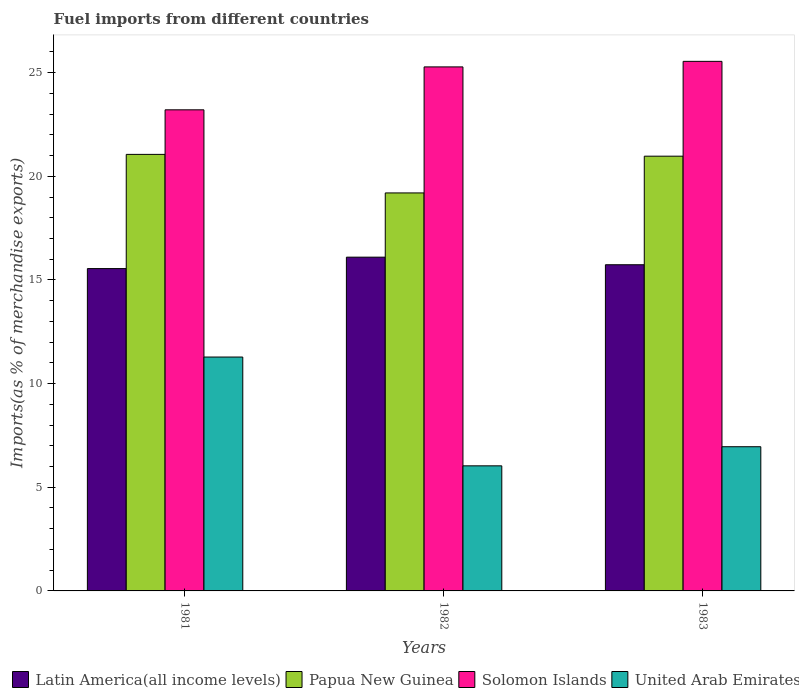Are the number of bars on each tick of the X-axis equal?
Provide a short and direct response. Yes. What is the percentage of imports to different countries in Papua New Guinea in 1982?
Your answer should be very brief. 19.2. Across all years, what is the maximum percentage of imports to different countries in Solomon Islands?
Give a very brief answer. 25.54. Across all years, what is the minimum percentage of imports to different countries in Latin America(all income levels)?
Your answer should be compact. 15.55. In which year was the percentage of imports to different countries in United Arab Emirates minimum?
Give a very brief answer. 1982. What is the total percentage of imports to different countries in Solomon Islands in the graph?
Make the answer very short. 74.03. What is the difference between the percentage of imports to different countries in Latin America(all income levels) in 1981 and that in 1983?
Keep it short and to the point. -0.19. What is the difference between the percentage of imports to different countries in Papua New Guinea in 1982 and the percentage of imports to different countries in Solomon Islands in 1983?
Provide a succinct answer. -6.35. What is the average percentage of imports to different countries in Latin America(all income levels) per year?
Your answer should be compact. 15.79. In the year 1983, what is the difference between the percentage of imports to different countries in Papua New Guinea and percentage of imports to different countries in United Arab Emirates?
Provide a short and direct response. 14.01. In how many years, is the percentage of imports to different countries in Solomon Islands greater than 7 %?
Keep it short and to the point. 3. What is the ratio of the percentage of imports to different countries in Solomon Islands in 1981 to that in 1982?
Offer a very short reply. 0.92. Is the percentage of imports to different countries in Latin America(all income levels) in 1981 less than that in 1982?
Offer a very short reply. Yes. Is the difference between the percentage of imports to different countries in Papua New Guinea in 1982 and 1983 greater than the difference between the percentage of imports to different countries in United Arab Emirates in 1982 and 1983?
Offer a very short reply. No. What is the difference between the highest and the second highest percentage of imports to different countries in United Arab Emirates?
Keep it short and to the point. 4.33. What is the difference between the highest and the lowest percentage of imports to different countries in Solomon Islands?
Ensure brevity in your answer.  2.34. What does the 2nd bar from the left in 1981 represents?
Ensure brevity in your answer.  Papua New Guinea. What does the 1st bar from the right in 1981 represents?
Your answer should be compact. United Arab Emirates. How many years are there in the graph?
Provide a short and direct response. 3. Does the graph contain grids?
Your answer should be very brief. No. Where does the legend appear in the graph?
Your answer should be compact. Bottom left. What is the title of the graph?
Keep it short and to the point. Fuel imports from different countries. What is the label or title of the Y-axis?
Offer a terse response. Imports(as % of merchandise exports). What is the Imports(as % of merchandise exports) of Latin America(all income levels) in 1981?
Provide a succinct answer. 15.55. What is the Imports(as % of merchandise exports) in Papua New Guinea in 1981?
Your answer should be compact. 21.06. What is the Imports(as % of merchandise exports) in Solomon Islands in 1981?
Your answer should be compact. 23.21. What is the Imports(as % of merchandise exports) of United Arab Emirates in 1981?
Your response must be concise. 11.28. What is the Imports(as % of merchandise exports) in Latin America(all income levels) in 1982?
Provide a short and direct response. 16.1. What is the Imports(as % of merchandise exports) in Papua New Guinea in 1982?
Your answer should be compact. 19.2. What is the Imports(as % of merchandise exports) in Solomon Islands in 1982?
Provide a short and direct response. 25.28. What is the Imports(as % of merchandise exports) in United Arab Emirates in 1982?
Offer a very short reply. 6.03. What is the Imports(as % of merchandise exports) in Latin America(all income levels) in 1983?
Your answer should be very brief. 15.73. What is the Imports(as % of merchandise exports) of Papua New Guinea in 1983?
Your answer should be compact. 20.97. What is the Imports(as % of merchandise exports) of Solomon Islands in 1983?
Provide a short and direct response. 25.54. What is the Imports(as % of merchandise exports) in United Arab Emirates in 1983?
Make the answer very short. 6.96. Across all years, what is the maximum Imports(as % of merchandise exports) in Latin America(all income levels)?
Offer a very short reply. 16.1. Across all years, what is the maximum Imports(as % of merchandise exports) of Papua New Guinea?
Offer a terse response. 21.06. Across all years, what is the maximum Imports(as % of merchandise exports) of Solomon Islands?
Your answer should be very brief. 25.54. Across all years, what is the maximum Imports(as % of merchandise exports) in United Arab Emirates?
Your response must be concise. 11.28. Across all years, what is the minimum Imports(as % of merchandise exports) of Latin America(all income levels)?
Your response must be concise. 15.55. Across all years, what is the minimum Imports(as % of merchandise exports) in Papua New Guinea?
Your response must be concise. 19.2. Across all years, what is the minimum Imports(as % of merchandise exports) of Solomon Islands?
Ensure brevity in your answer.  23.21. Across all years, what is the minimum Imports(as % of merchandise exports) in United Arab Emirates?
Provide a short and direct response. 6.03. What is the total Imports(as % of merchandise exports) of Latin America(all income levels) in the graph?
Make the answer very short. 47.38. What is the total Imports(as % of merchandise exports) of Papua New Guinea in the graph?
Keep it short and to the point. 61.22. What is the total Imports(as % of merchandise exports) in Solomon Islands in the graph?
Provide a short and direct response. 74.03. What is the total Imports(as % of merchandise exports) of United Arab Emirates in the graph?
Your answer should be very brief. 24.27. What is the difference between the Imports(as % of merchandise exports) in Latin America(all income levels) in 1981 and that in 1982?
Ensure brevity in your answer.  -0.55. What is the difference between the Imports(as % of merchandise exports) of Papua New Guinea in 1981 and that in 1982?
Make the answer very short. 1.86. What is the difference between the Imports(as % of merchandise exports) of Solomon Islands in 1981 and that in 1982?
Give a very brief answer. -2.07. What is the difference between the Imports(as % of merchandise exports) of United Arab Emirates in 1981 and that in 1982?
Provide a succinct answer. 5.25. What is the difference between the Imports(as % of merchandise exports) in Latin America(all income levels) in 1981 and that in 1983?
Provide a succinct answer. -0.19. What is the difference between the Imports(as % of merchandise exports) of Papua New Guinea in 1981 and that in 1983?
Make the answer very short. 0.09. What is the difference between the Imports(as % of merchandise exports) of Solomon Islands in 1981 and that in 1983?
Provide a short and direct response. -2.34. What is the difference between the Imports(as % of merchandise exports) of United Arab Emirates in 1981 and that in 1983?
Your answer should be very brief. 4.33. What is the difference between the Imports(as % of merchandise exports) in Latin America(all income levels) in 1982 and that in 1983?
Your response must be concise. 0.37. What is the difference between the Imports(as % of merchandise exports) in Papua New Guinea in 1982 and that in 1983?
Make the answer very short. -1.77. What is the difference between the Imports(as % of merchandise exports) in Solomon Islands in 1982 and that in 1983?
Ensure brevity in your answer.  -0.27. What is the difference between the Imports(as % of merchandise exports) of United Arab Emirates in 1982 and that in 1983?
Keep it short and to the point. -0.92. What is the difference between the Imports(as % of merchandise exports) in Latin America(all income levels) in 1981 and the Imports(as % of merchandise exports) in Papua New Guinea in 1982?
Keep it short and to the point. -3.65. What is the difference between the Imports(as % of merchandise exports) of Latin America(all income levels) in 1981 and the Imports(as % of merchandise exports) of Solomon Islands in 1982?
Provide a succinct answer. -9.73. What is the difference between the Imports(as % of merchandise exports) of Latin America(all income levels) in 1981 and the Imports(as % of merchandise exports) of United Arab Emirates in 1982?
Your answer should be compact. 9.51. What is the difference between the Imports(as % of merchandise exports) in Papua New Guinea in 1981 and the Imports(as % of merchandise exports) in Solomon Islands in 1982?
Offer a very short reply. -4.22. What is the difference between the Imports(as % of merchandise exports) of Papua New Guinea in 1981 and the Imports(as % of merchandise exports) of United Arab Emirates in 1982?
Give a very brief answer. 15.02. What is the difference between the Imports(as % of merchandise exports) in Solomon Islands in 1981 and the Imports(as % of merchandise exports) in United Arab Emirates in 1982?
Keep it short and to the point. 17.17. What is the difference between the Imports(as % of merchandise exports) of Latin America(all income levels) in 1981 and the Imports(as % of merchandise exports) of Papua New Guinea in 1983?
Give a very brief answer. -5.42. What is the difference between the Imports(as % of merchandise exports) in Latin America(all income levels) in 1981 and the Imports(as % of merchandise exports) in Solomon Islands in 1983?
Give a very brief answer. -10. What is the difference between the Imports(as % of merchandise exports) of Latin America(all income levels) in 1981 and the Imports(as % of merchandise exports) of United Arab Emirates in 1983?
Provide a succinct answer. 8.59. What is the difference between the Imports(as % of merchandise exports) in Papua New Guinea in 1981 and the Imports(as % of merchandise exports) in Solomon Islands in 1983?
Give a very brief answer. -4.49. What is the difference between the Imports(as % of merchandise exports) of Papua New Guinea in 1981 and the Imports(as % of merchandise exports) of United Arab Emirates in 1983?
Make the answer very short. 14.1. What is the difference between the Imports(as % of merchandise exports) of Solomon Islands in 1981 and the Imports(as % of merchandise exports) of United Arab Emirates in 1983?
Ensure brevity in your answer.  16.25. What is the difference between the Imports(as % of merchandise exports) in Latin America(all income levels) in 1982 and the Imports(as % of merchandise exports) in Papua New Guinea in 1983?
Your response must be concise. -4.87. What is the difference between the Imports(as % of merchandise exports) of Latin America(all income levels) in 1982 and the Imports(as % of merchandise exports) of Solomon Islands in 1983?
Offer a very short reply. -9.44. What is the difference between the Imports(as % of merchandise exports) of Latin America(all income levels) in 1982 and the Imports(as % of merchandise exports) of United Arab Emirates in 1983?
Keep it short and to the point. 9.14. What is the difference between the Imports(as % of merchandise exports) of Papua New Guinea in 1982 and the Imports(as % of merchandise exports) of Solomon Islands in 1983?
Provide a succinct answer. -6.35. What is the difference between the Imports(as % of merchandise exports) in Papua New Guinea in 1982 and the Imports(as % of merchandise exports) in United Arab Emirates in 1983?
Your answer should be very brief. 12.24. What is the difference between the Imports(as % of merchandise exports) of Solomon Islands in 1982 and the Imports(as % of merchandise exports) of United Arab Emirates in 1983?
Your answer should be compact. 18.32. What is the average Imports(as % of merchandise exports) of Latin America(all income levels) per year?
Your answer should be very brief. 15.79. What is the average Imports(as % of merchandise exports) of Papua New Guinea per year?
Give a very brief answer. 20.41. What is the average Imports(as % of merchandise exports) in Solomon Islands per year?
Your response must be concise. 24.68. What is the average Imports(as % of merchandise exports) in United Arab Emirates per year?
Make the answer very short. 8.09. In the year 1981, what is the difference between the Imports(as % of merchandise exports) in Latin America(all income levels) and Imports(as % of merchandise exports) in Papua New Guinea?
Make the answer very short. -5.51. In the year 1981, what is the difference between the Imports(as % of merchandise exports) in Latin America(all income levels) and Imports(as % of merchandise exports) in Solomon Islands?
Your answer should be compact. -7.66. In the year 1981, what is the difference between the Imports(as % of merchandise exports) in Latin America(all income levels) and Imports(as % of merchandise exports) in United Arab Emirates?
Provide a succinct answer. 4.27. In the year 1981, what is the difference between the Imports(as % of merchandise exports) in Papua New Guinea and Imports(as % of merchandise exports) in Solomon Islands?
Ensure brevity in your answer.  -2.15. In the year 1981, what is the difference between the Imports(as % of merchandise exports) of Papua New Guinea and Imports(as % of merchandise exports) of United Arab Emirates?
Your response must be concise. 9.78. In the year 1981, what is the difference between the Imports(as % of merchandise exports) in Solomon Islands and Imports(as % of merchandise exports) in United Arab Emirates?
Your answer should be very brief. 11.93. In the year 1982, what is the difference between the Imports(as % of merchandise exports) of Latin America(all income levels) and Imports(as % of merchandise exports) of Papua New Guinea?
Offer a terse response. -3.1. In the year 1982, what is the difference between the Imports(as % of merchandise exports) in Latin America(all income levels) and Imports(as % of merchandise exports) in Solomon Islands?
Your response must be concise. -9.18. In the year 1982, what is the difference between the Imports(as % of merchandise exports) in Latin America(all income levels) and Imports(as % of merchandise exports) in United Arab Emirates?
Make the answer very short. 10.07. In the year 1982, what is the difference between the Imports(as % of merchandise exports) in Papua New Guinea and Imports(as % of merchandise exports) in Solomon Islands?
Ensure brevity in your answer.  -6.08. In the year 1982, what is the difference between the Imports(as % of merchandise exports) of Papua New Guinea and Imports(as % of merchandise exports) of United Arab Emirates?
Provide a short and direct response. 13.16. In the year 1982, what is the difference between the Imports(as % of merchandise exports) of Solomon Islands and Imports(as % of merchandise exports) of United Arab Emirates?
Ensure brevity in your answer.  19.24. In the year 1983, what is the difference between the Imports(as % of merchandise exports) of Latin America(all income levels) and Imports(as % of merchandise exports) of Papua New Guinea?
Offer a very short reply. -5.24. In the year 1983, what is the difference between the Imports(as % of merchandise exports) in Latin America(all income levels) and Imports(as % of merchandise exports) in Solomon Islands?
Provide a short and direct response. -9.81. In the year 1983, what is the difference between the Imports(as % of merchandise exports) in Latin America(all income levels) and Imports(as % of merchandise exports) in United Arab Emirates?
Your answer should be compact. 8.78. In the year 1983, what is the difference between the Imports(as % of merchandise exports) in Papua New Guinea and Imports(as % of merchandise exports) in Solomon Islands?
Provide a short and direct response. -4.57. In the year 1983, what is the difference between the Imports(as % of merchandise exports) of Papua New Guinea and Imports(as % of merchandise exports) of United Arab Emirates?
Offer a very short reply. 14.01. In the year 1983, what is the difference between the Imports(as % of merchandise exports) in Solomon Islands and Imports(as % of merchandise exports) in United Arab Emirates?
Offer a very short reply. 18.59. What is the ratio of the Imports(as % of merchandise exports) of Latin America(all income levels) in 1981 to that in 1982?
Provide a short and direct response. 0.97. What is the ratio of the Imports(as % of merchandise exports) of Papua New Guinea in 1981 to that in 1982?
Offer a terse response. 1.1. What is the ratio of the Imports(as % of merchandise exports) of Solomon Islands in 1981 to that in 1982?
Ensure brevity in your answer.  0.92. What is the ratio of the Imports(as % of merchandise exports) in United Arab Emirates in 1981 to that in 1982?
Offer a terse response. 1.87. What is the ratio of the Imports(as % of merchandise exports) of Latin America(all income levels) in 1981 to that in 1983?
Your response must be concise. 0.99. What is the ratio of the Imports(as % of merchandise exports) of Papua New Guinea in 1981 to that in 1983?
Provide a short and direct response. 1. What is the ratio of the Imports(as % of merchandise exports) in Solomon Islands in 1981 to that in 1983?
Your response must be concise. 0.91. What is the ratio of the Imports(as % of merchandise exports) in United Arab Emirates in 1981 to that in 1983?
Provide a short and direct response. 1.62. What is the ratio of the Imports(as % of merchandise exports) in Latin America(all income levels) in 1982 to that in 1983?
Offer a terse response. 1.02. What is the ratio of the Imports(as % of merchandise exports) in Papua New Guinea in 1982 to that in 1983?
Keep it short and to the point. 0.92. What is the ratio of the Imports(as % of merchandise exports) of Solomon Islands in 1982 to that in 1983?
Offer a very short reply. 0.99. What is the ratio of the Imports(as % of merchandise exports) of United Arab Emirates in 1982 to that in 1983?
Offer a terse response. 0.87. What is the difference between the highest and the second highest Imports(as % of merchandise exports) in Latin America(all income levels)?
Provide a short and direct response. 0.37. What is the difference between the highest and the second highest Imports(as % of merchandise exports) in Papua New Guinea?
Offer a terse response. 0.09. What is the difference between the highest and the second highest Imports(as % of merchandise exports) in Solomon Islands?
Provide a short and direct response. 0.27. What is the difference between the highest and the second highest Imports(as % of merchandise exports) of United Arab Emirates?
Your answer should be compact. 4.33. What is the difference between the highest and the lowest Imports(as % of merchandise exports) in Latin America(all income levels)?
Provide a short and direct response. 0.55. What is the difference between the highest and the lowest Imports(as % of merchandise exports) of Papua New Guinea?
Give a very brief answer. 1.86. What is the difference between the highest and the lowest Imports(as % of merchandise exports) of Solomon Islands?
Keep it short and to the point. 2.34. What is the difference between the highest and the lowest Imports(as % of merchandise exports) of United Arab Emirates?
Keep it short and to the point. 5.25. 